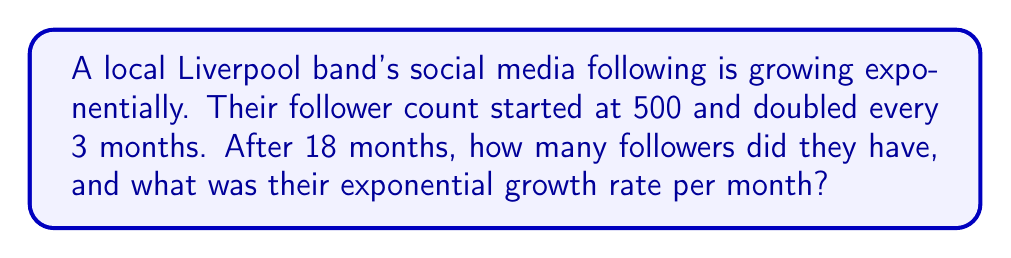Could you help me with this problem? Let's approach this step-by-step:

1) First, let's determine how many times the follower count doubled in 18 months:
   18 months ÷ 3 months = 6 doublings

2) We can express this as an exponential equation:
   $$ \text{Followers after 18 months} = 500 \cdot 2^6 $$

3) Calculate the result:
   $$ 500 \cdot 2^6 = 500 \cdot 64 = 32,000 \text{ followers} $$

4) Now, let's find the monthly growth rate. We can use the exponential growth formula:
   $$ A = P(1+r)^t $$
   Where A is the final amount, P is the initial amount, r is the growth rate, and t is the time period.

5) Plugging in our values:
   $$ 32,000 = 500(1+r)^{18} $$

6) Solve for r:
   $$ \frac{32,000}{500} = (1+r)^{18} $$
   $$ 64 = (1+r)^{18} $$
   $$ \sqrt[18]{64} = 1+r $$
   $$ 1.2457... = 1+r $$
   $$ r = 0.2457... = 24.57\% $$

Therefore, the monthly growth rate is approximately 24.57%.
Answer: 32,000 followers; 24.57% monthly growth rate 